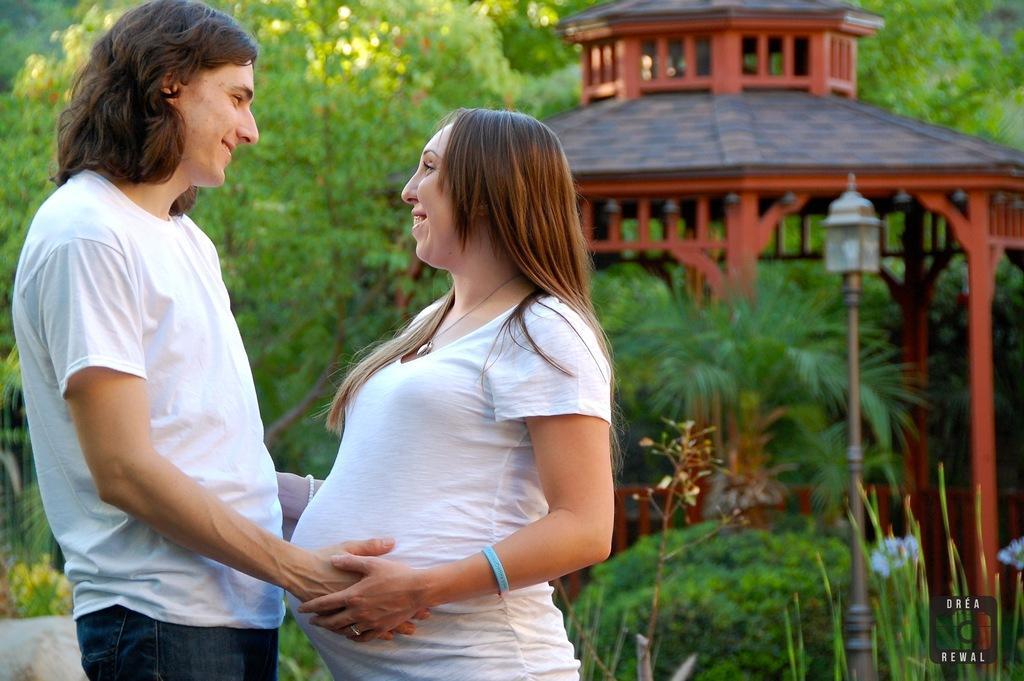How many people are in the image? There are two people standing in the image. What is the facial expression of the people in the image? The people are smiling. What can be seen in the background of the image? There are trees, a shed, and a light pole visible in the background. What is the purpose of the thing that the people are trading in the image? There is no indication in the image that the people are trading anything, nor is there any "thing" present that could be traded. 